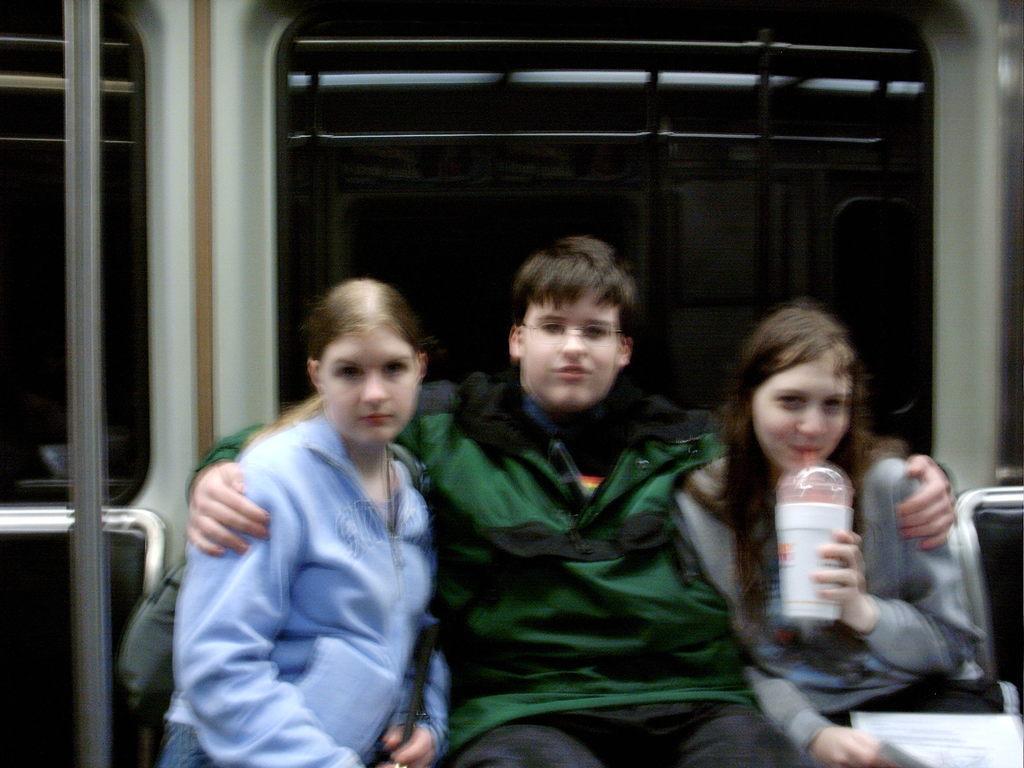How would you summarize this image in a sentence or two? In this image we can see three persons one male and two females, male person wearing green color jacket sitting in between two females and a person sitting on right to him holding some glass in her hands and in the background of the image we can see window, steel rods. 